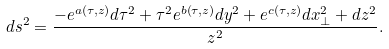Convert formula to latex. <formula><loc_0><loc_0><loc_500><loc_500>d s ^ { 2 } = \frac { - e ^ { a \left ( \tau , z \right ) } d \tau ^ { 2 } + \tau ^ { 2 } e ^ { b \left ( \tau , z \right ) } d y ^ { 2 } + e ^ { c \left ( \tau , z \right ) } d x _ { \perp } ^ { 2 } + d z ^ { 2 } } { z ^ { 2 } } .</formula> 